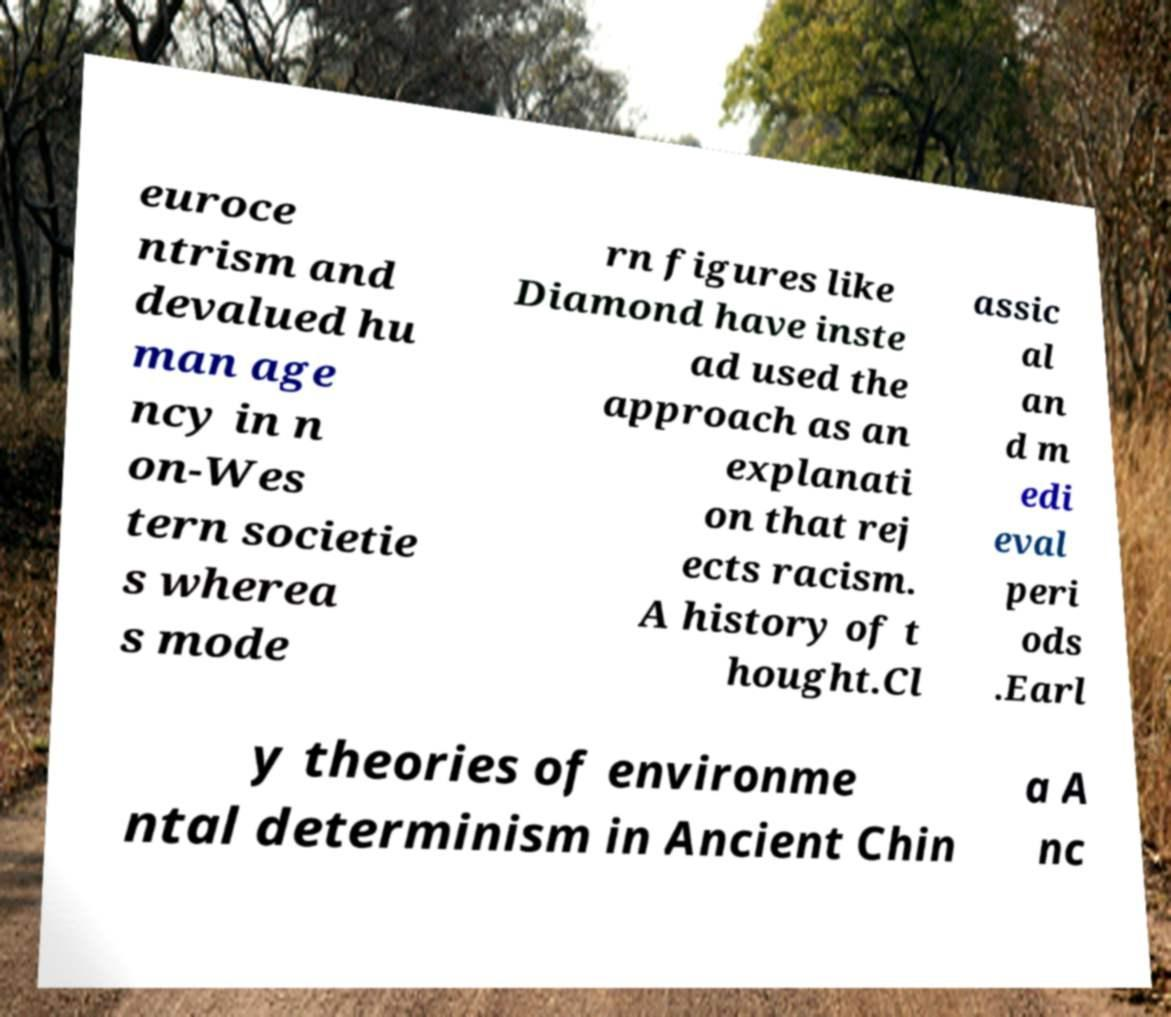Could you assist in decoding the text presented in this image and type it out clearly? euroce ntrism and devalued hu man age ncy in n on-Wes tern societie s wherea s mode rn figures like Diamond have inste ad used the approach as an explanati on that rej ects racism. A history of t hought.Cl assic al an d m edi eval peri ods .Earl y theories of environme ntal determinism in Ancient Chin a A nc 